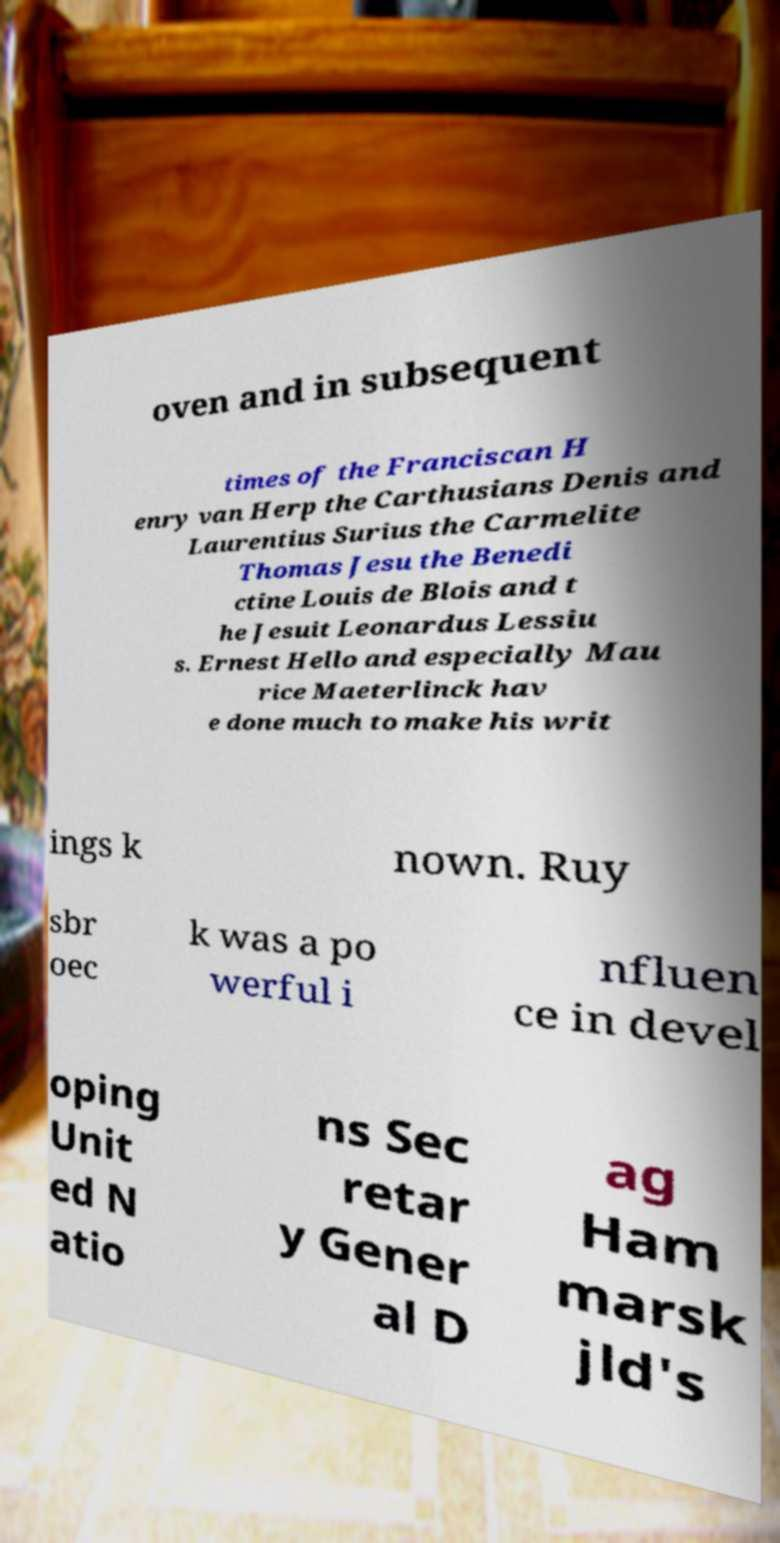There's text embedded in this image that I need extracted. Can you transcribe it verbatim? oven and in subsequent times of the Franciscan H enry van Herp the Carthusians Denis and Laurentius Surius the Carmelite Thomas Jesu the Benedi ctine Louis de Blois and t he Jesuit Leonardus Lessiu s. Ernest Hello and especially Mau rice Maeterlinck hav e done much to make his writ ings k nown. Ruy sbr oec k was a po werful i nfluen ce in devel oping Unit ed N atio ns Sec retar y Gener al D ag Ham marsk jld's 